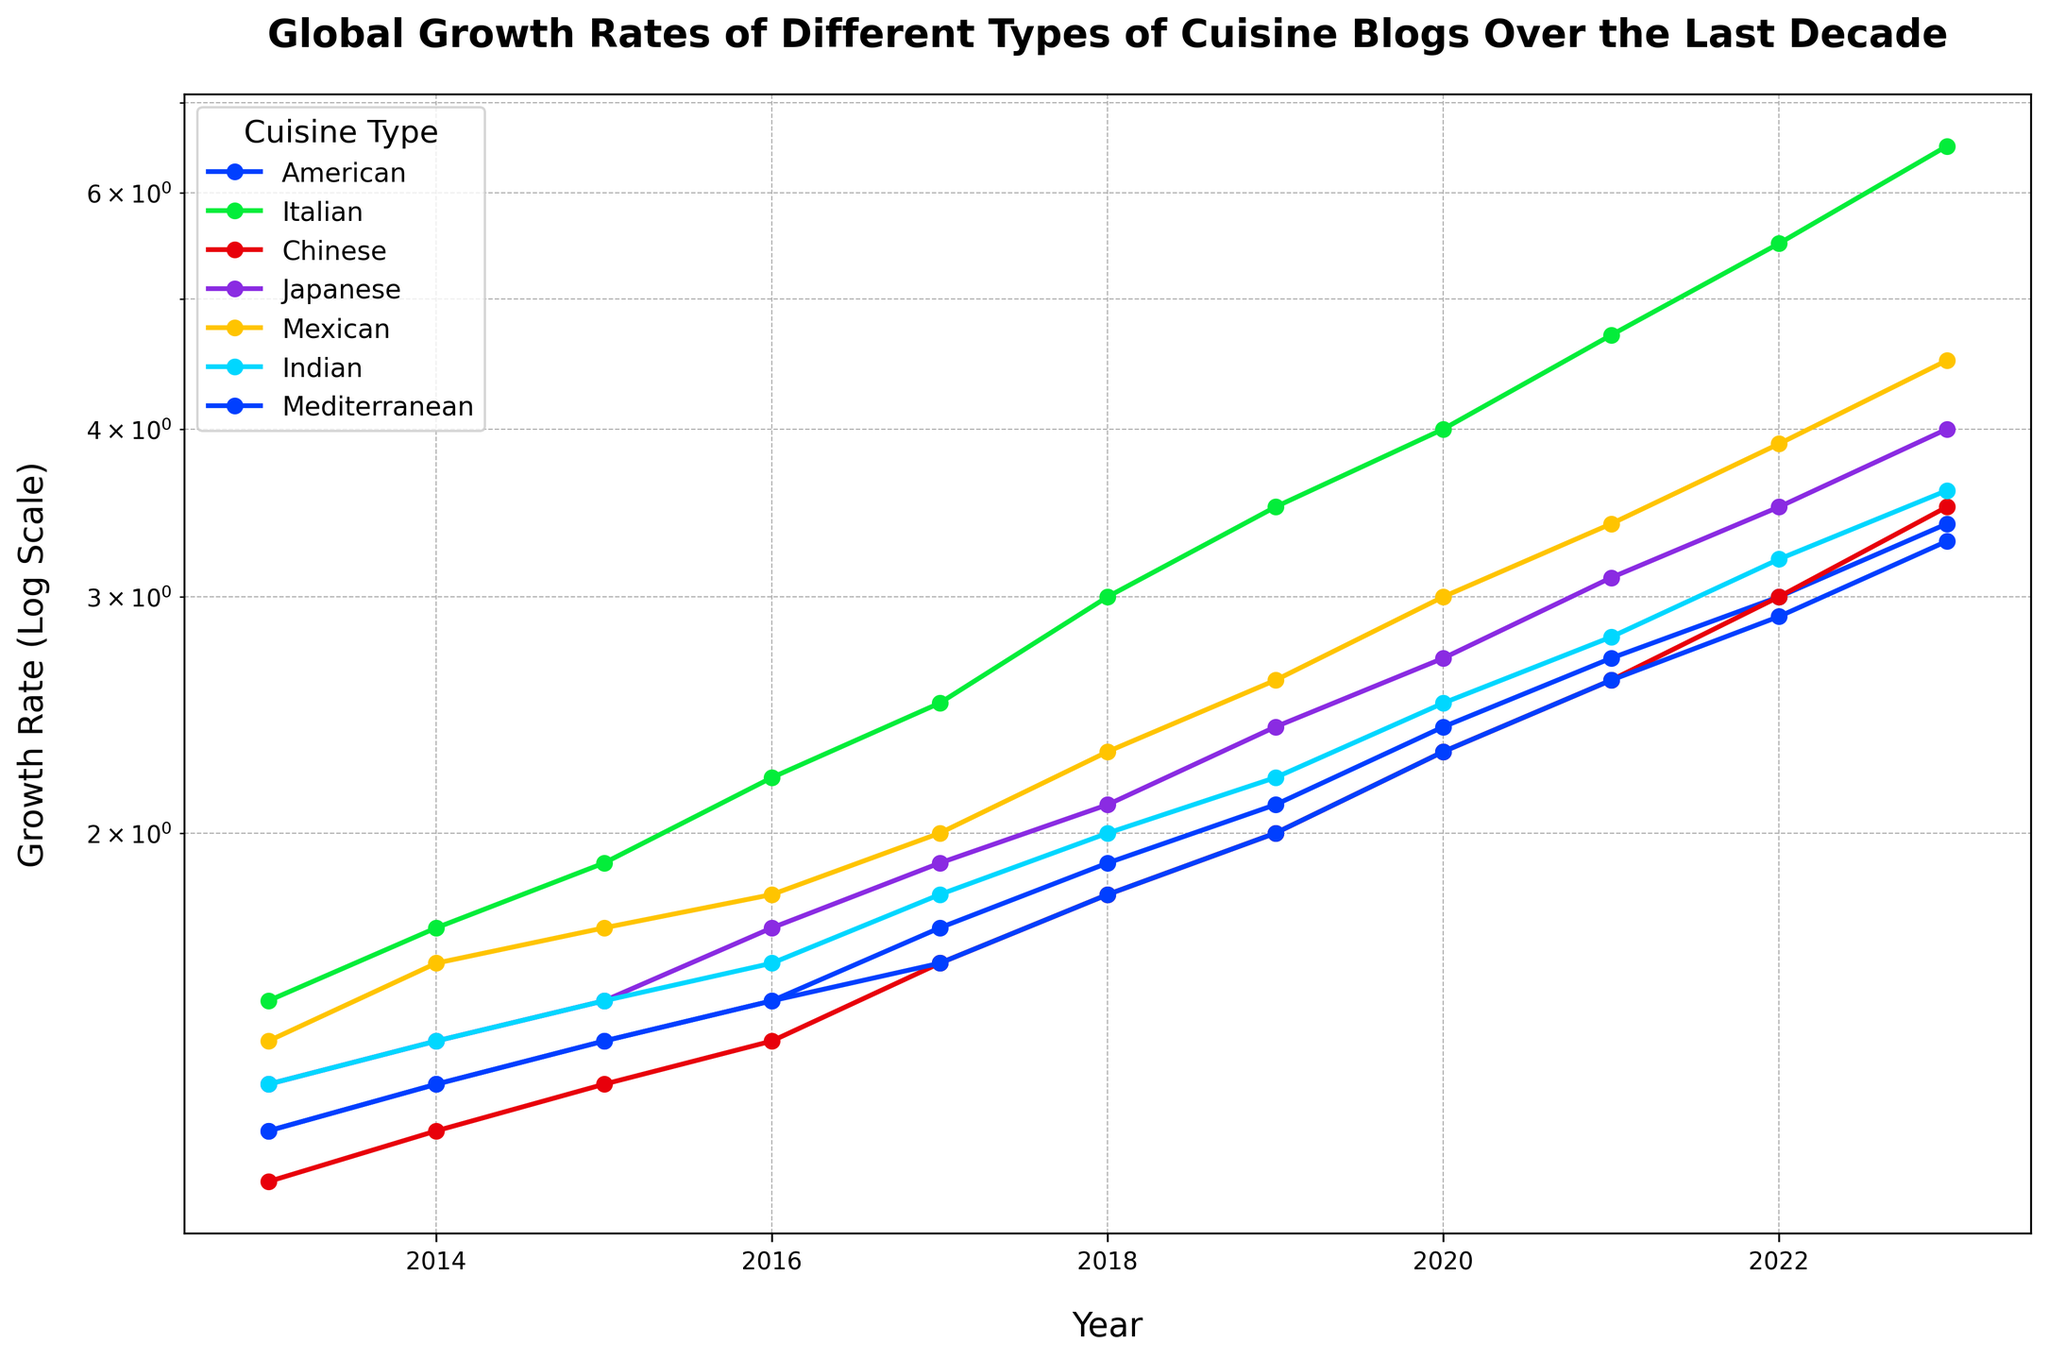What's the overall trend of the Italian cuisine blog growth rate over the last decade? The trend of the Italian cuisine blog growth rate shows a steady increase every year from 2013 to 2023 on a logarithmic scale. Initially, in 2013, the growth rate starts at 1.5 and by 2023 it reaches 6.5.
Answer: Steady increase Which cuisine experienced the highest growth rate in 2023? By observing the endpoints for 2023 on the logarithmic scale, the Italian cuisine has the highest growth rate, reaching a value of 6.5.
Answer: Italian How does the growth rate of Japanese cuisine in 2018 compare to that of Mexican cuisine in the same year? In 2018, the growth rate of Japanese cuisine is 2.1 while that of Mexican cuisine is 2.3. Therefore, the growth rate of Mexican cuisine is higher than that of Japanese cuisine in 2018.
Answer: Mexican What is the difference between the growth rates of Indian and Mediterranean cuisines in 2020? In 2020, the growth rate for Indian cuisine is 2.5 and for Mediterranean cuisine is 2.3. The difference between the two values is 2.5 - 2.3 = 0.2.
Answer: 0.2 Compare the highest growth rates of American and Chinese cuisines over the last decade. Which one is higher and by how much? The highest growth rate for American cuisine is in 2023 at 3.4, and for Chinese cuisine, it is also in 2023 at 3.5. The Chinese cuisine’s highest growth rate is slightly higher by 3.5 - 3.4 = 0.1.
Answer: Chinese by 0.1 What is the average growth rate of Mexican cuisine between 2016 and 2019? The growth rates for Mexican cuisine between 2016 and 2019 are 1.8, 2.0, 2.3, and 2.6. Adding them gives 1.8 + 2.0 + 2.3 + 2.6 = 8.7. The average is then 8.7 / 4 = 2.175.
Answer: 2.175 Which cuisine's growth rate doubled from 2015 to 2023? By comparing the growth rates, the Mexican cuisine growth rate doubles from 1.7 in 2015 to 3.4 in 2023. Similarly, Indian cuisine doubles from 1.5 in 2015 to 3.6 in 2023, and Mediterranean from 1.4 in 2015 to 2.9 in 2023.
Answer: Mexican, Indian, Mediterranean How does the growth rate of American cuisine in 2017 compare to Indian cuisine in the same year? In 2017, the growth rate of American cuisine is 1.7, while the growth rate of Indian cuisine is 1.8. Therefore, the growth rate of Indian cuisine is slightly higher than that of American cuisine in 2017.
Answer: Indian 